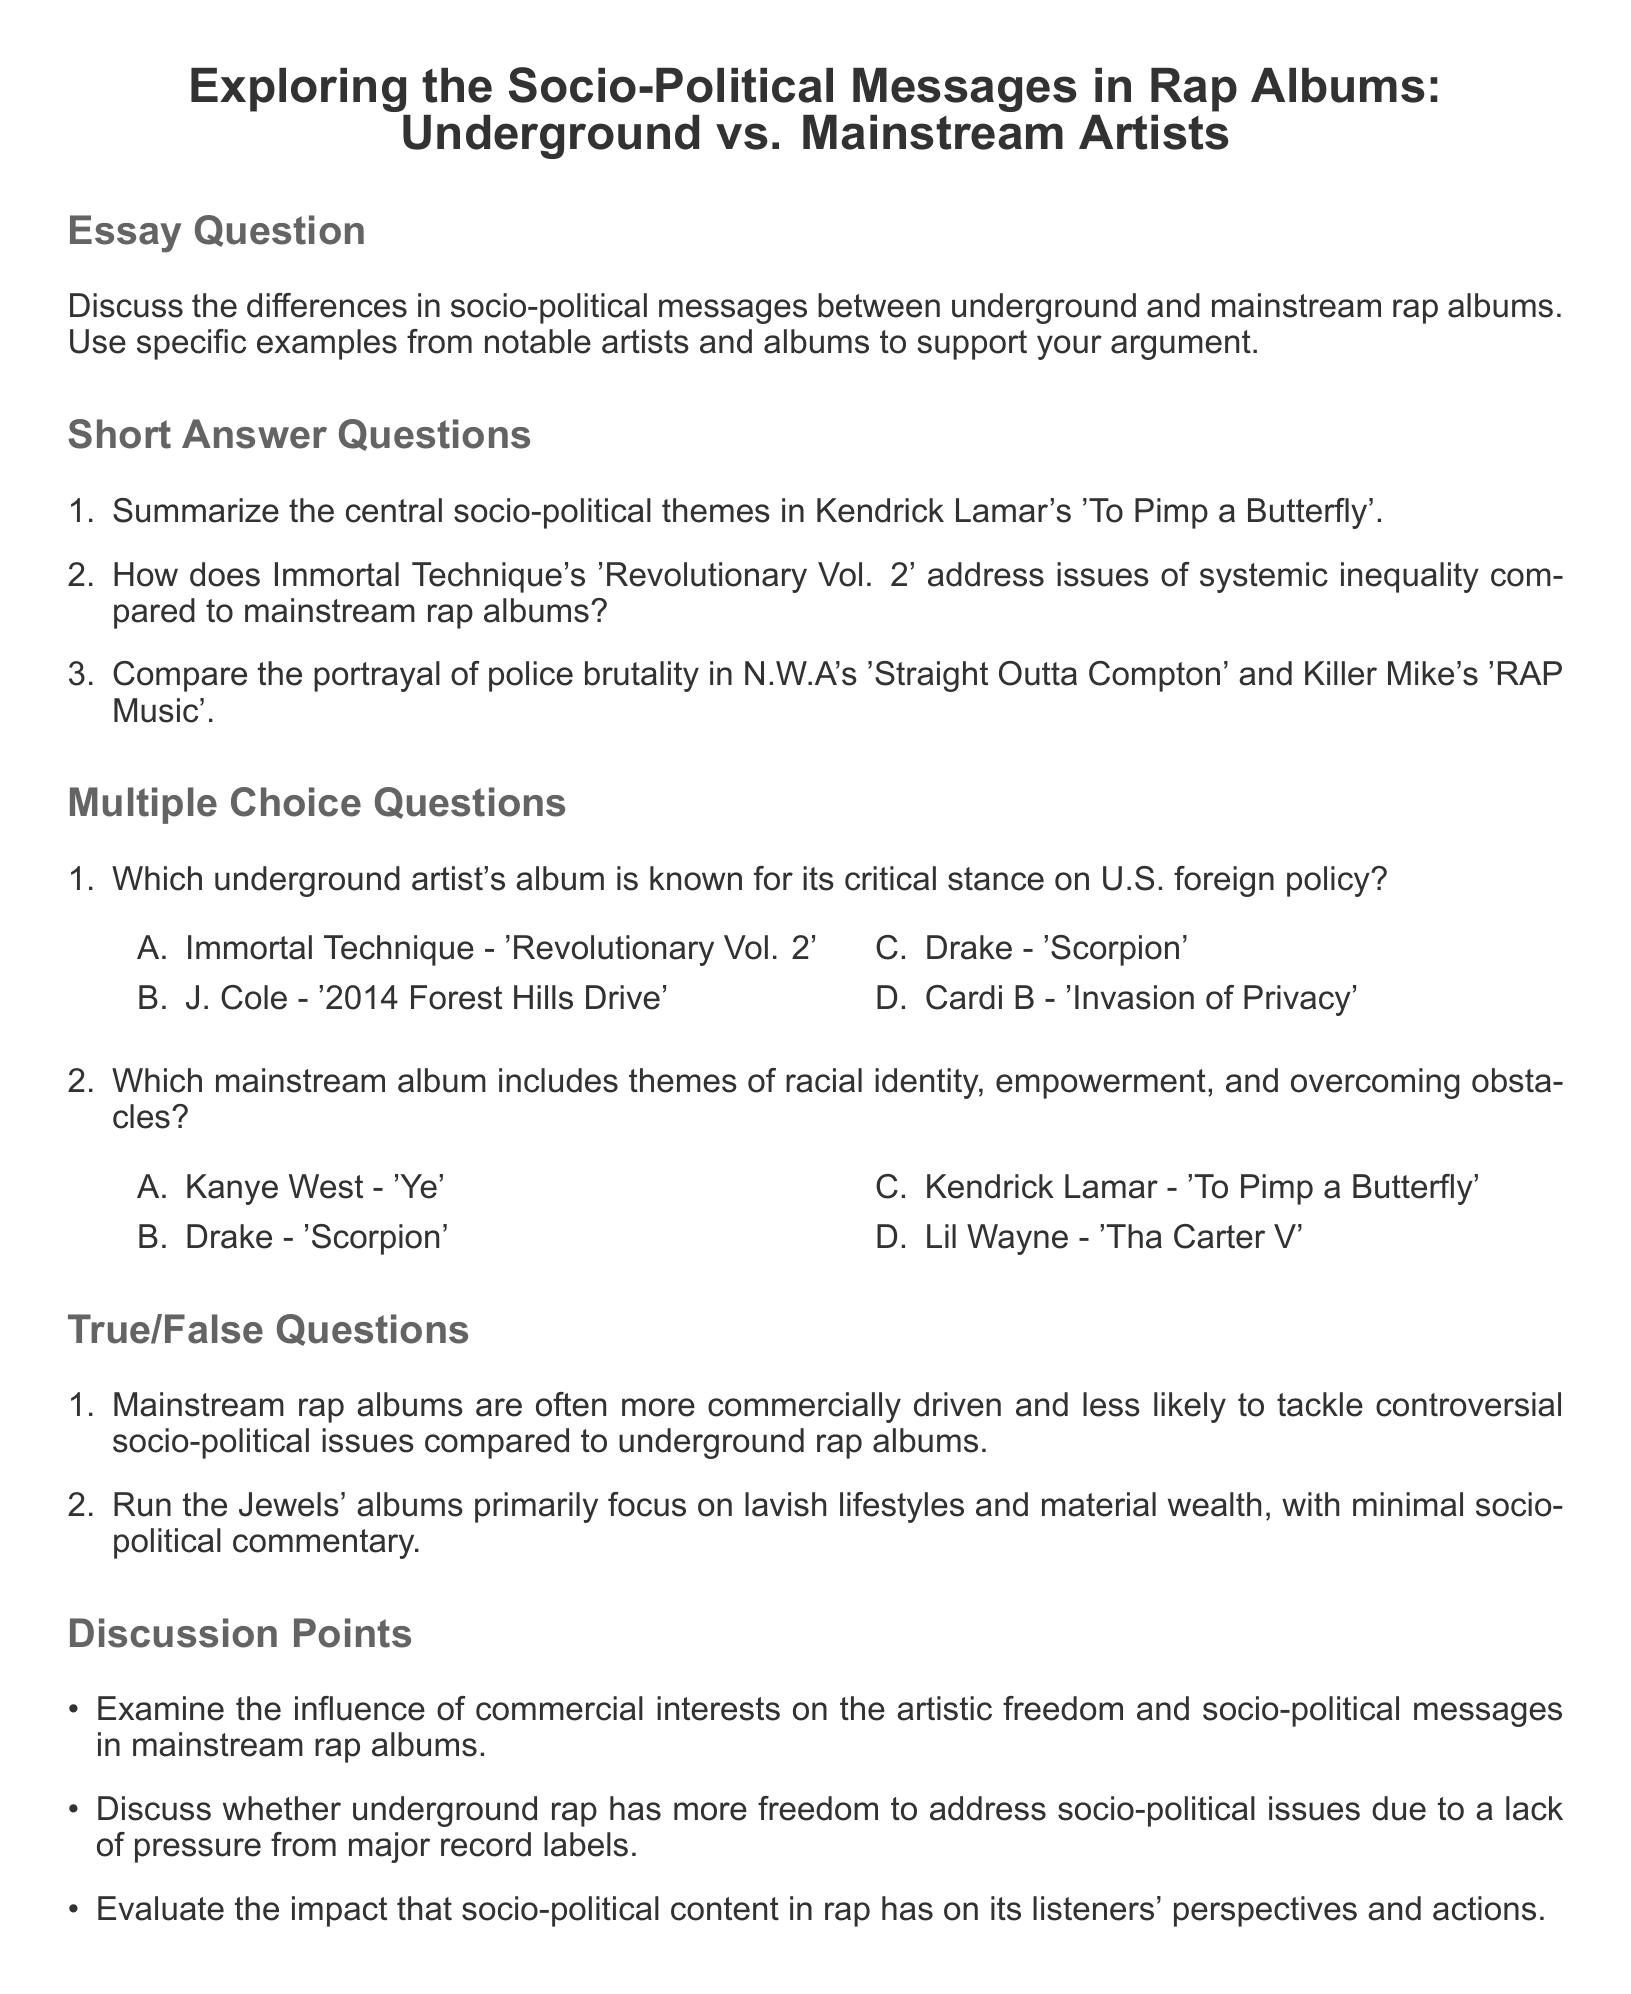What is the title of the essay question? The title of the essay question is located at the beginning of the document, specifically under the section labeled "Essay Question."
Answer: Exploring the Socio-Political Messages in Rap Albums: Underground vs. Mainstream Artists Who is the artist behind 'To Pimp a Butterfly'? The artist's name is mentioned in the short answer questions section, where the album 'To Pimp a Butterfly' is discussed.
Answer: Kendrick Lamar How many short answer questions are listed in the document? The number of short answer questions can be found by counting the bullets under the "Short Answer Questions" section.
Answer: 3 Which underground artist's album focuses on systemic inequality? This information can be retrieved from the second short answer question that compares Immortal Technique's themes with mainstream rap.
Answer: Immortal Technique What is the correct answer for the multiple choice question about the album addressing U.S. foreign policy? The answers for the multiple choice questions are provided in the "Multiple Choice Questions" section where the correct option is identified.
Answer: Immortal Technique - 'Revolutionary Vol. 2' Is the statement "Run the Jewels' albums primarily focus on lavish lifestyles and material wealth" true or false? The statement's validity is assessed in the "True/False Questions" section, which poses it for evaluation.
Answer: False What is one of the discussion points in the document? The discussion points are listed as bullet items in the respective section, which focus on socio-political content in rap.
Answer: Influence of commercial interests on artistic freedom How many multiple choice questions are there? The count of multiple choice questions can be found by simply counting the items in that section of the document.
Answer: 2 What is the label for the questions regarding the socio-political influence of rap? This label is found at the start of a section dedicated to exploring broader themes related to the essay's topic.
Answer: Discussion Points 